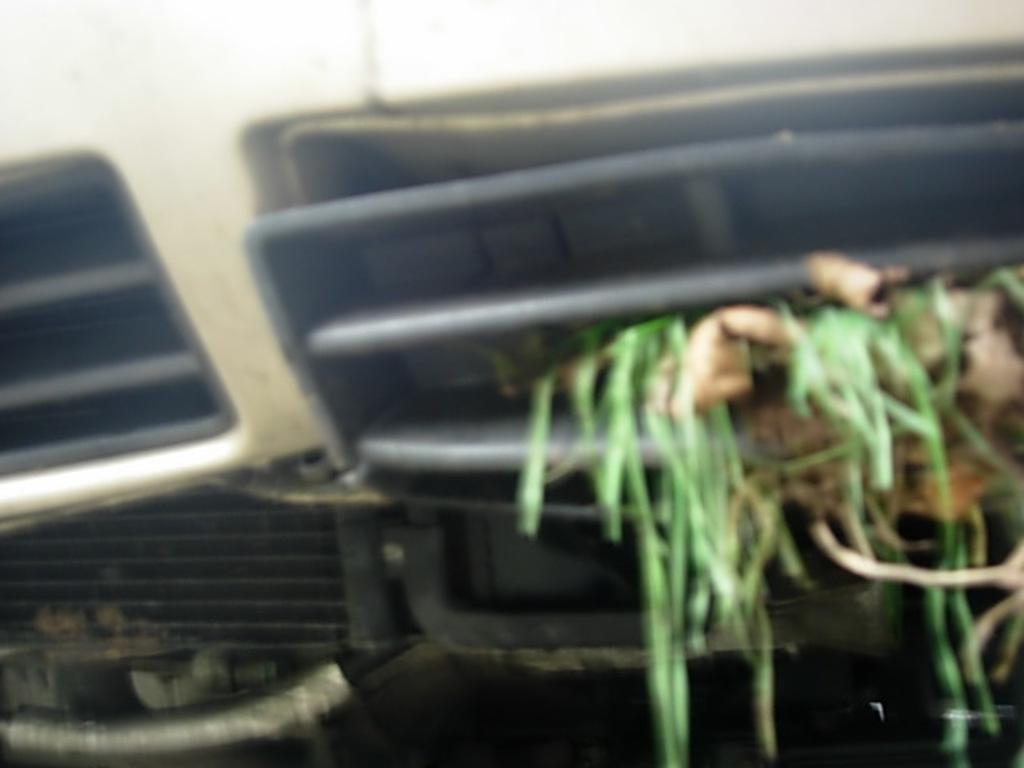Can you describe this image briefly? In this picture we can see a vehicle parts and grass. 